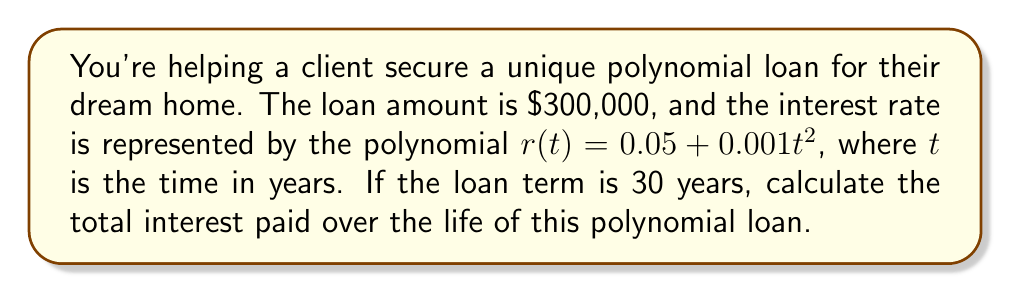Help me with this question. Let's approach this step-by-step:

1) The interest rate is given by $r(t) = 0.05 + 0.001t^2$

2) To find the total interest, we need to integrate the interest rate function over the loan term:

   $$\text{Total Interest} = 300000 \int_0^{30} (0.05 + 0.001t^2) dt$$

3) Let's solve the integral:

   $$300000 \int_0^{30} (0.05 + 0.001t^2) dt$$
   $$= 300000 [0.05t + \frac{0.001t^3}{3}]_0^{30}$$

4) Evaluate the integral:

   $$= 300000 [(0.05 \cdot 30 + \frac{0.001 \cdot 30^3}{3}) - (0.05 \cdot 0 + \frac{0.001 \cdot 0^3}{3})]$$
   $$= 300000 [1.5 + \frac{27}{3}]$$
   $$= 300000 [1.5 + 9]$$
   $$= 300000 \cdot 10.5$$

5) Calculate the final result:

   $$= 3,150,000$$

Thus, the total interest paid over the life of this polynomial loan is $3,150,000.
Answer: $3,150,000 